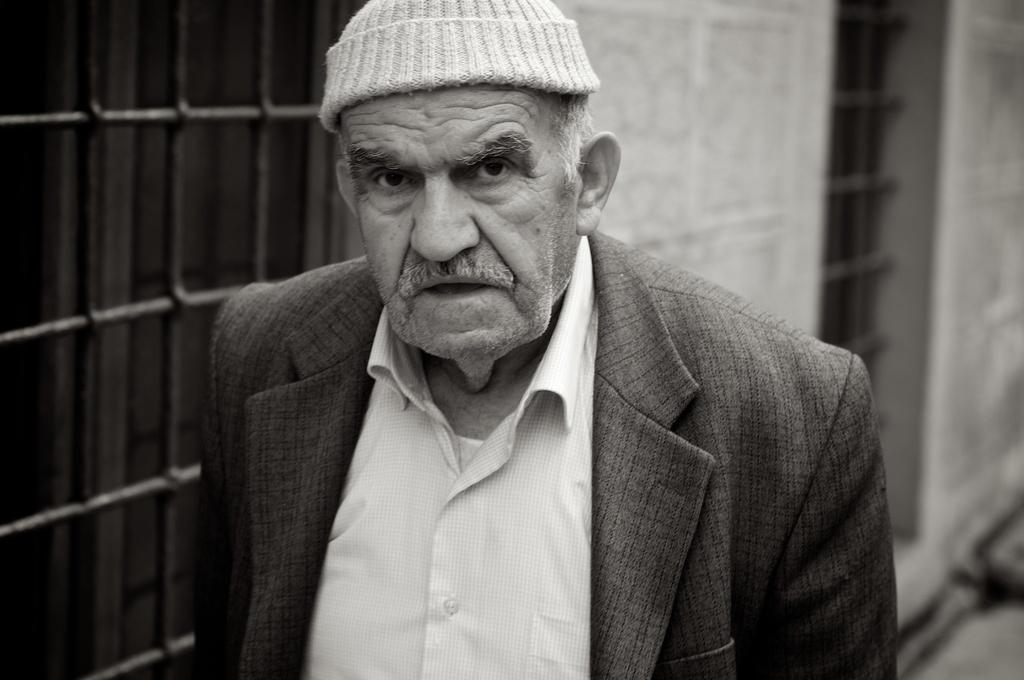Who is present in the image? There is a person in the image. What is the person wearing? The person is wearing a dress and a cap. What can be seen in the background of the image? There are windows visible in the background of the image. What type of structure do the windows belong to? The windows belong to a building. How many cherries are on the person's account in the image? There are no cherries or accounts mentioned in the image; it only features a person wearing a dress and cap with windows in the background. 